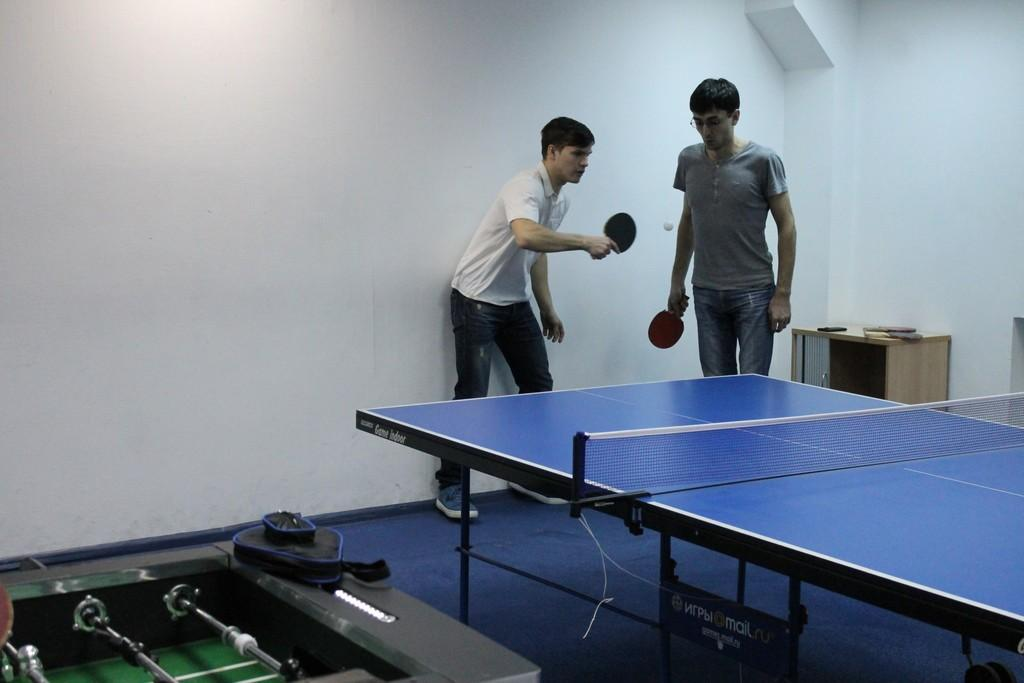How many people are in the image? There are two people in the image. What activity are the people engaged in? The two people are playing table tennis. What is the mindset of the table tennis players in the image? The provided facts do not give any information about the mindset of the table tennis players, so it cannot be determined from the image. 